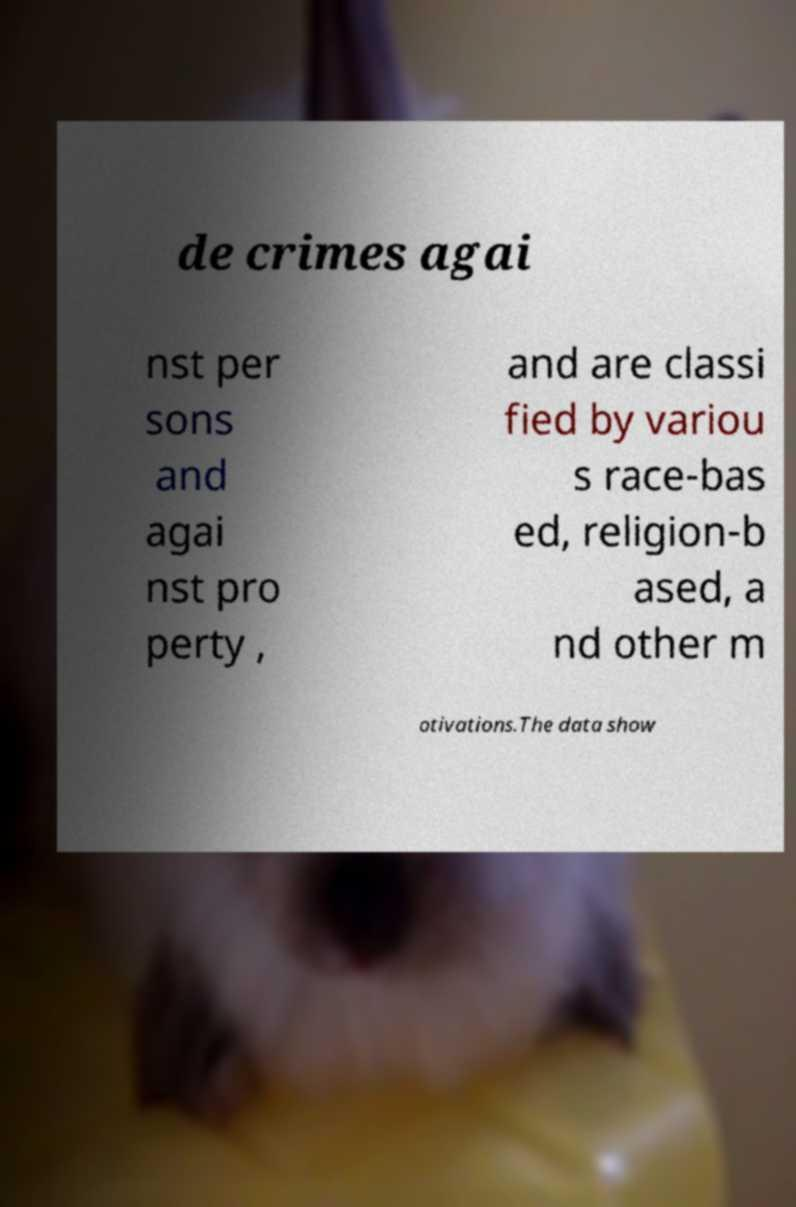Could you assist in decoding the text presented in this image and type it out clearly? de crimes agai nst per sons and agai nst pro perty , and are classi fied by variou s race-bas ed, religion-b ased, a nd other m otivations.The data show 